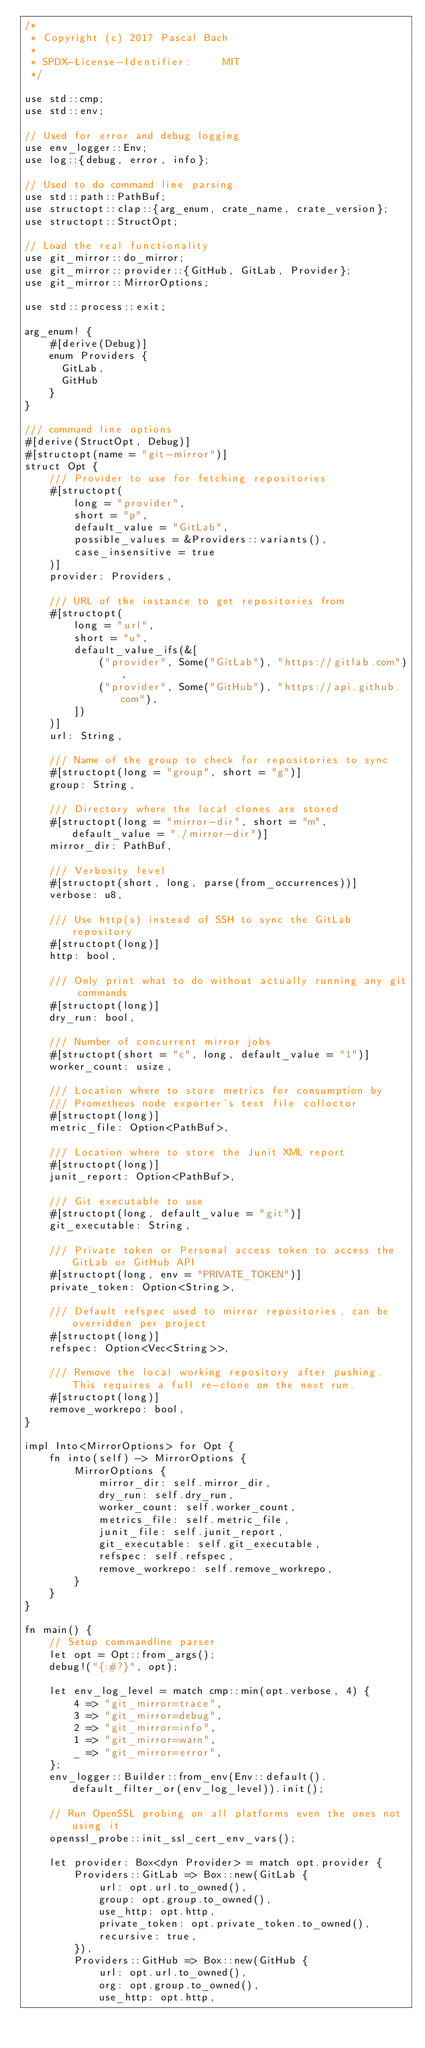<code> <loc_0><loc_0><loc_500><loc_500><_Rust_>/*
 * Copyright (c) 2017 Pascal Bach
 *
 * SPDX-License-Identifier:     MIT
 */

use std::cmp;
use std::env;

// Used for error and debug logging
use env_logger::Env;
use log::{debug, error, info};

// Used to do command line parsing
use std::path::PathBuf;
use structopt::clap::{arg_enum, crate_name, crate_version};
use structopt::StructOpt;

// Load the real functionality
use git_mirror::do_mirror;
use git_mirror::provider::{GitHub, GitLab, Provider};
use git_mirror::MirrorOptions;

use std::process::exit;

arg_enum! {
    #[derive(Debug)]
    enum Providers {
      GitLab,
      GitHub
    }
}

/// command line options
#[derive(StructOpt, Debug)]
#[structopt(name = "git-mirror")]
struct Opt {
    /// Provider to use for fetching repositories
    #[structopt(
        long = "provider",
        short = "p",
        default_value = "GitLab",
        possible_values = &Providers::variants(),
        case_insensitive = true
    )]
    provider: Providers,

    /// URL of the instance to get repositories from
    #[structopt(
        long = "url",
        short = "u",
        default_value_ifs(&[
            ("provider", Some("GitLab"), "https://gitlab.com"),
            ("provider", Some("GitHub"), "https://api.github.com"),
        ])
    )]
    url: String,

    /// Name of the group to check for repositories to sync
    #[structopt(long = "group", short = "g")]
    group: String,

    /// Directory where the local clones are stored
    #[structopt(long = "mirror-dir", short = "m", default_value = "./mirror-dir")]
    mirror_dir: PathBuf,

    /// Verbosity level
    #[structopt(short, long, parse(from_occurrences))]
    verbose: u8,

    /// Use http(s) instead of SSH to sync the GitLab repository
    #[structopt(long)]
    http: bool,

    /// Only print what to do without actually running any git commands
    #[structopt(long)]
    dry_run: bool,

    /// Number of concurrent mirror jobs
    #[structopt(short = "c", long, default_value = "1")]
    worker_count: usize,

    /// Location where to store metrics for consumption by
    /// Prometheus node exporter's text file colloctor
    #[structopt(long)]
    metric_file: Option<PathBuf>,

    /// Location where to store the Junit XML report
    #[structopt(long)]
    junit_report: Option<PathBuf>,

    /// Git executable to use
    #[structopt(long, default_value = "git")]
    git_executable: String,

    /// Private token or Personal access token to access the GitLab or GitHub API
    #[structopt(long, env = "PRIVATE_TOKEN")]
    private_token: Option<String>,

    /// Default refspec used to mirror repositories, can be overridden per project
    #[structopt(long)]
    refspec: Option<Vec<String>>,

    /// Remove the local working repository after pushing. This requires a full re-clone on the next run.
    #[structopt(long)]
    remove_workrepo: bool,
}

impl Into<MirrorOptions> for Opt {
    fn into(self) -> MirrorOptions {
        MirrorOptions {
            mirror_dir: self.mirror_dir,
            dry_run: self.dry_run,
            worker_count: self.worker_count,
            metrics_file: self.metric_file,
            junit_file: self.junit_report,
            git_executable: self.git_executable,
            refspec: self.refspec,
            remove_workrepo: self.remove_workrepo,
        }
    }
}

fn main() {
    // Setup commandline parser
    let opt = Opt::from_args();
    debug!("{:#?}", opt);

    let env_log_level = match cmp::min(opt.verbose, 4) {
        4 => "git_mirror=trace",
        3 => "git_mirror=debug",
        2 => "git_mirror=info",
        1 => "git_mirror=warn",
        _ => "git_mirror=error",
    };
    env_logger::Builder::from_env(Env::default().default_filter_or(env_log_level)).init();

    // Run OpenSSL probing on all platforms even the ones not using it
    openssl_probe::init_ssl_cert_env_vars();

    let provider: Box<dyn Provider> = match opt.provider {
        Providers::GitLab => Box::new(GitLab {
            url: opt.url.to_owned(),
            group: opt.group.to_owned(),
            use_http: opt.http,
            private_token: opt.private_token.to_owned(),
            recursive: true,
        }),
        Providers::GitHub => Box::new(GitHub {
            url: opt.url.to_owned(),
            org: opt.group.to_owned(),
            use_http: opt.http,</code> 